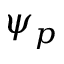<formula> <loc_0><loc_0><loc_500><loc_500>\psi _ { p }</formula> 